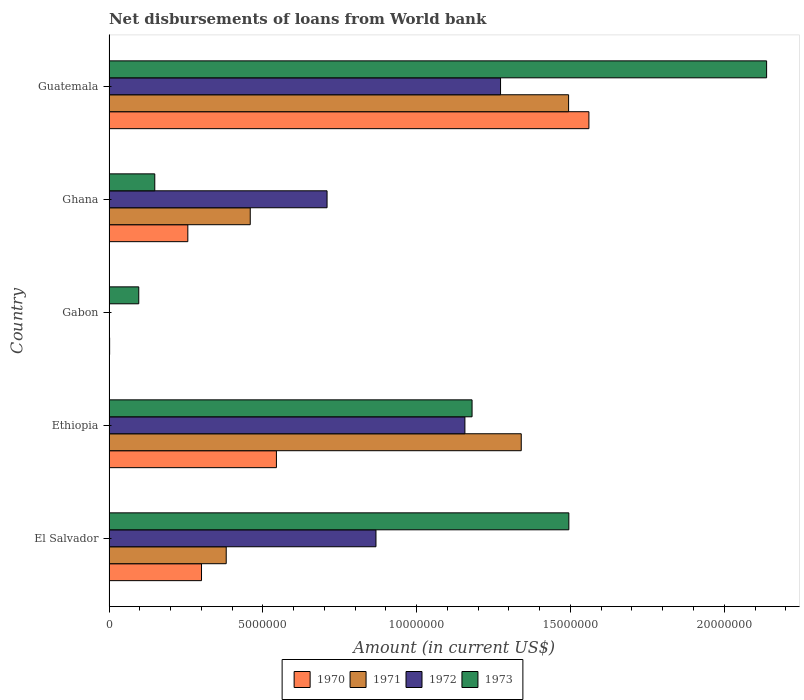How many different coloured bars are there?
Ensure brevity in your answer.  4. Are the number of bars per tick equal to the number of legend labels?
Provide a short and direct response. No. How many bars are there on the 2nd tick from the bottom?
Your response must be concise. 4. What is the label of the 5th group of bars from the top?
Your response must be concise. El Salvador. In how many cases, is the number of bars for a given country not equal to the number of legend labels?
Make the answer very short. 1. What is the amount of loan disbursed from World Bank in 1972 in Gabon?
Offer a very short reply. 0. Across all countries, what is the maximum amount of loan disbursed from World Bank in 1973?
Give a very brief answer. 2.14e+07. In which country was the amount of loan disbursed from World Bank in 1972 maximum?
Give a very brief answer. Guatemala. What is the total amount of loan disbursed from World Bank in 1973 in the graph?
Your response must be concise. 5.06e+07. What is the difference between the amount of loan disbursed from World Bank in 1972 in Ethiopia and that in Guatemala?
Your answer should be very brief. -1.16e+06. What is the difference between the amount of loan disbursed from World Bank in 1970 in El Salvador and the amount of loan disbursed from World Bank in 1972 in Ethiopia?
Ensure brevity in your answer.  -8.56e+06. What is the average amount of loan disbursed from World Bank in 1973 per country?
Your answer should be very brief. 1.01e+07. What is the difference between the amount of loan disbursed from World Bank in 1973 and amount of loan disbursed from World Bank in 1970 in Guatemala?
Your answer should be very brief. 5.78e+06. In how many countries, is the amount of loan disbursed from World Bank in 1972 greater than 19000000 US$?
Provide a short and direct response. 0. What is the ratio of the amount of loan disbursed from World Bank in 1973 in Ghana to that in Guatemala?
Give a very brief answer. 0.07. Is the difference between the amount of loan disbursed from World Bank in 1973 in Ethiopia and Guatemala greater than the difference between the amount of loan disbursed from World Bank in 1970 in Ethiopia and Guatemala?
Provide a succinct answer. Yes. What is the difference between the highest and the second highest amount of loan disbursed from World Bank in 1972?
Offer a very short reply. 1.16e+06. What is the difference between the highest and the lowest amount of loan disbursed from World Bank in 1973?
Give a very brief answer. 2.04e+07. In how many countries, is the amount of loan disbursed from World Bank in 1971 greater than the average amount of loan disbursed from World Bank in 1971 taken over all countries?
Keep it short and to the point. 2. Is it the case that in every country, the sum of the amount of loan disbursed from World Bank in 1971 and amount of loan disbursed from World Bank in 1973 is greater than the sum of amount of loan disbursed from World Bank in 1970 and amount of loan disbursed from World Bank in 1972?
Give a very brief answer. No. Is it the case that in every country, the sum of the amount of loan disbursed from World Bank in 1972 and amount of loan disbursed from World Bank in 1973 is greater than the amount of loan disbursed from World Bank in 1970?
Ensure brevity in your answer.  Yes. How many bars are there?
Keep it short and to the point. 18. Are all the bars in the graph horizontal?
Make the answer very short. Yes. How many countries are there in the graph?
Ensure brevity in your answer.  5. What is the difference between two consecutive major ticks on the X-axis?
Make the answer very short. 5.00e+06. Are the values on the major ticks of X-axis written in scientific E-notation?
Keep it short and to the point. No. Does the graph contain any zero values?
Keep it short and to the point. Yes. Where does the legend appear in the graph?
Keep it short and to the point. Bottom center. What is the title of the graph?
Provide a short and direct response. Net disbursements of loans from World bank. Does "1995" appear as one of the legend labels in the graph?
Make the answer very short. No. What is the label or title of the X-axis?
Provide a short and direct response. Amount (in current US$). What is the Amount (in current US$) in 1970 in El Salvador?
Keep it short and to the point. 3.01e+06. What is the Amount (in current US$) in 1971 in El Salvador?
Provide a succinct answer. 3.81e+06. What is the Amount (in current US$) in 1972 in El Salvador?
Your answer should be very brief. 8.68e+06. What is the Amount (in current US$) in 1973 in El Salvador?
Give a very brief answer. 1.49e+07. What is the Amount (in current US$) of 1970 in Ethiopia?
Give a very brief answer. 5.44e+06. What is the Amount (in current US$) in 1971 in Ethiopia?
Your response must be concise. 1.34e+07. What is the Amount (in current US$) in 1972 in Ethiopia?
Give a very brief answer. 1.16e+07. What is the Amount (in current US$) of 1973 in Ethiopia?
Give a very brief answer. 1.18e+07. What is the Amount (in current US$) in 1970 in Gabon?
Your answer should be compact. 2.00e+04. What is the Amount (in current US$) in 1973 in Gabon?
Your response must be concise. 9.67e+05. What is the Amount (in current US$) in 1970 in Ghana?
Provide a short and direct response. 2.56e+06. What is the Amount (in current US$) in 1971 in Ghana?
Offer a very short reply. 4.59e+06. What is the Amount (in current US$) in 1972 in Ghana?
Your answer should be compact. 7.09e+06. What is the Amount (in current US$) of 1973 in Ghana?
Ensure brevity in your answer.  1.49e+06. What is the Amount (in current US$) in 1970 in Guatemala?
Offer a terse response. 1.56e+07. What is the Amount (in current US$) in 1971 in Guatemala?
Provide a succinct answer. 1.49e+07. What is the Amount (in current US$) in 1972 in Guatemala?
Provide a succinct answer. 1.27e+07. What is the Amount (in current US$) in 1973 in Guatemala?
Offer a terse response. 2.14e+07. Across all countries, what is the maximum Amount (in current US$) of 1970?
Your response must be concise. 1.56e+07. Across all countries, what is the maximum Amount (in current US$) in 1971?
Your answer should be very brief. 1.49e+07. Across all countries, what is the maximum Amount (in current US$) of 1972?
Make the answer very short. 1.27e+07. Across all countries, what is the maximum Amount (in current US$) of 1973?
Offer a very short reply. 2.14e+07. Across all countries, what is the minimum Amount (in current US$) in 1973?
Offer a terse response. 9.67e+05. What is the total Amount (in current US$) in 1970 in the graph?
Offer a terse response. 2.66e+07. What is the total Amount (in current US$) in 1971 in the graph?
Offer a very short reply. 3.67e+07. What is the total Amount (in current US$) in 1972 in the graph?
Make the answer very short. 4.01e+07. What is the total Amount (in current US$) of 1973 in the graph?
Offer a very short reply. 5.06e+07. What is the difference between the Amount (in current US$) in 1970 in El Salvador and that in Ethiopia?
Offer a very short reply. -2.44e+06. What is the difference between the Amount (in current US$) in 1971 in El Salvador and that in Ethiopia?
Keep it short and to the point. -9.59e+06. What is the difference between the Amount (in current US$) in 1972 in El Salvador and that in Ethiopia?
Your answer should be compact. -2.89e+06. What is the difference between the Amount (in current US$) of 1973 in El Salvador and that in Ethiopia?
Offer a very short reply. 3.15e+06. What is the difference between the Amount (in current US$) of 1970 in El Salvador and that in Gabon?
Make the answer very short. 2.99e+06. What is the difference between the Amount (in current US$) in 1973 in El Salvador and that in Gabon?
Your response must be concise. 1.40e+07. What is the difference between the Amount (in current US$) of 1970 in El Salvador and that in Ghana?
Ensure brevity in your answer.  4.45e+05. What is the difference between the Amount (in current US$) in 1971 in El Salvador and that in Ghana?
Make the answer very short. -7.81e+05. What is the difference between the Amount (in current US$) of 1972 in El Salvador and that in Ghana?
Keep it short and to the point. 1.59e+06. What is the difference between the Amount (in current US$) of 1973 in El Salvador and that in Ghana?
Provide a succinct answer. 1.35e+07. What is the difference between the Amount (in current US$) of 1970 in El Salvador and that in Guatemala?
Keep it short and to the point. -1.26e+07. What is the difference between the Amount (in current US$) in 1971 in El Salvador and that in Guatemala?
Your response must be concise. -1.11e+07. What is the difference between the Amount (in current US$) of 1972 in El Salvador and that in Guatemala?
Your response must be concise. -4.05e+06. What is the difference between the Amount (in current US$) in 1973 in El Salvador and that in Guatemala?
Your response must be concise. -6.43e+06. What is the difference between the Amount (in current US$) in 1970 in Ethiopia and that in Gabon?
Your response must be concise. 5.42e+06. What is the difference between the Amount (in current US$) in 1973 in Ethiopia and that in Gabon?
Make the answer very short. 1.08e+07. What is the difference between the Amount (in current US$) of 1970 in Ethiopia and that in Ghana?
Ensure brevity in your answer.  2.88e+06. What is the difference between the Amount (in current US$) of 1971 in Ethiopia and that in Ghana?
Your answer should be very brief. 8.81e+06. What is the difference between the Amount (in current US$) in 1972 in Ethiopia and that in Ghana?
Offer a terse response. 4.48e+06. What is the difference between the Amount (in current US$) of 1973 in Ethiopia and that in Ghana?
Ensure brevity in your answer.  1.03e+07. What is the difference between the Amount (in current US$) in 1970 in Ethiopia and that in Guatemala?
Your answer should be compact. -1.02e+07. What is the difference between the Amount (in current US$) of 1971 in Ethiopia and that in Guatemala?
Your answer should be very brief. -1.54e+06. What is the difference between the Amount (in current US$) of 1972 in Ethiopia and that in Guatemala?
Your answer should be very brief. -1.16e+06. What is the difference between the Amount (in current US$) in 1973 in Ethiopia and that in Guatemala?
Your response must be concise. -9.58e+06. What is the difference between the Amount (in current US$) in 1970 in Gabon and that in Ghana?
Offer a terse response. -2.54e+06. What is the difference between the Amount (in current US$) in 1973 in Gabon and that in Ghana?
Provide a short and direct response. -5.21e+05. What is the difference between the Amount (in current US$) of 1970 in Gabon and that in Guatemala?
Your answer should be compact. -1.56e+07. What is the difference between the Amount (in current US$) of 1973 in Gabon and that in Guatemala?
Give a very brief answer. -2.04e+07. What is the difference between the Amount (in current US$) of 1970 in Ghana and that in Guatemala?
Ensure brevity in your answer.  -1.30e+07. What is the difference between the Amount (in current US$) in 1971 in Ghana and that in Guatemala?
Offer a terse response. -1.03e+07. What is the difference between the Amount (in current US$) in 1972 in Ghana and that in Guatemala?
Give a very brief answer. -5.64e+06. What is the difference between the Amount (in current US$) in 1973 in Ghana and that in Guatemala?
Keep it short and to the point. -1.99e+07. What is the difference between the Amount (in current US$) of 1970 in El Salvador and the Amount (in current US$) of 1971 in Ethiopia?
Provide a succinct answer. -1.04e+07. What is the difference between the Amount (in current US$) of 1970 in El Salvador and the Amount (in current US$) of 1972 in Ethiopia?
Ensure brevity in your answer.  -8.56e+06. What is the difference between the Amount (in current US$) in 1970 in El Salvador and the Amount (in current US$) in 1973 in Ethiopia?
Provide a succinct answer. -8.80e+06. What is the difference between the Amount (in current US$) of 1971 in El Salvador and the Amount (in current US$) of 1972 in Ethiopia?
Offer a very short reply. -7.76e+06. What is the difference between the Amount (in current US$) of 1971 in El Salvador and the Amount (in current US$) of 1973 in Ethiopia?
Offer a very short reply. -7.99e+06. What is the difference between the Amount (in current US$) of 1972 in El Salvador and the Amount (in current US$) of 1973 in Ethiopia?
Your response must be concise. -3.12e+06. What is the difference between the Amount (in current US$) in 1970 in El Salvador and the Amount (in current US$) in 1973 in Gabon?
Give a very brief answer. 2.04e+06. What is the difference between the Amount (in current US$) in 1971 in El Salvador and the Amount (in current US$) in 1973 in Gabon?
Your answer should be compact. 2.84e+06. What is the difference between the Amount (in current US$) in 1972 in El Salvador and the Amount (in current US$) in 1973 in Gabon?
Give a very brief answer. 7.71e+06. What is the difference between the Amount (in current US$) of 1970 in El Salvador and the Amount (in current US$) of 1971 in Ghana?
Ensure brevity in your answer.  -1.58e+06. What is the difference between the Amount (in current US$) of 1970 in El Salvador and the Amount (in current US$) of 1972 in Ghana?
Ensure brevity in your answer.  -4.08e+06. What is the difference between the Amount (in current US$) of 1970 in El Salvador and the Amount (in current US$) of 1973 in Ghana?
Provide a short and direct response. 1.52e+06. What is the difference between the Amount (in current US$) in 1971 in El Salvador and the Amount (in current US$) in 1972 in Ghana?
Provide a succinct answer. -3.28e+06. What is the difference between the Amount (in current US$) of 1971 in El Salvador and the Amount (in current US$) of 1973 in Ghana?
Make the answer very short. 2.32e+06. What is the difference between the Amount (in current US$) of 1972 in El Salvador and the Amount (in current US$) of 1973 in Ghana?
Give a very brief answer. 7.19e+06. What is the difference between the Amount (in current US$) in 1970 in El Salvador and the Amount (in current US$) in 1971 in Guatemala?
Provide a succinct answer. -1.19e+07. What is the difference between the Amount (in current US$) in 1970 in El Salvador and the Amount (in current US$) in 1972 in Guatemala?
Ensure brevity in your answer.  -9.72e+06. What is the difference between the Amount (in current US$) of 1970 in El Salvador and the Amount (in current US$) of 1973 in Guatemala?
Your response must be concise. -1.84e+07. What is the difference between the Amount (in current US$) of 1971 in El Salvador and the Amount (in current US$) of 1972 in Guatemala?
Give a very brief answer. -8.92e+06. What is the difference between the Amount (in current US$) of 1971 in El Salvador and the Amount (in current US$) of 1973 in Guatemala?
Offer a terse response. -1.76e+07. What is the difference between the Amount (in current US$) in 1972 in El Salvador and the Amount (in current US$) in 1973 in Guatemala?
Keep it short and to the point. -1.27e+07. What is the difference between the Amount (in current US$) in 1970 in Ethiopia and the Amount (in current US$) in 1973 in Gabon?
Ensure brevity in your answer.  4.48e+06. What is the difference between the Amount (in current US$) in 1971 in Ethiopia and the Amount (in current US$) in 1973 in Gabon?
Give a very brief answer. 1.24e+07. What is the difference between the Amount (in current US$) of 1972 in Ethiopia and the Amount (in current US$) of 1973 in Gabon?
Make the answer very short. 1.06e+07. What is the difference between the Amount (in current US$) in 1970 in Ethiopia and the Amount (in current US$) in 1971 in Ghana?
Provide a short and direct response. 8.51e+05. What is the difference between the Amount (in current US$) in 1970 in Ethiopia and the Amount (in current US$) in 1972 in Ghana?
Give a very brief answer. -1.65e+06. What is the difference between the Amount (in current US$) in 1970 in Ethiopia and the Amount (in current US$) in 1973 in Ghana?
Provide a short and direct response. 3.95e+06. What is the difference between the Amount (in current US$) in 1971 in Ethiopia and the Amount (in current US$) in 1972 in Ghana?
Your response must be concise. 6.31e+06. What is the difference between the Amount (in current US$) in 1971 in Ethiopia and the Amount (in current US$) in 1973 in Ghana?
Provide a succinct answer. 1.19e+07. What is the difference between the Amount (in current US$) in 1972 in Ethiopia and the Amount (in current US$) in 1973 in Ghana?
Offer a terse response. 1.01e+07. What is the difference between the Amount (in current US$) of 1970 in Ethiopia and the Amount (in current US$) of 1971 in Guatemala?
Your answer should be compact. -9.50e+06. What is the difference between the Amount (in current US$) of 1970 in Ethiopia and the Amount (in current US$) of 1972 in Guatemala?
Give a very brief answer. -7.29e+06. What is the difference between the Amount (in current US$) in 1970 in Ethiopia and the Amount (in current US$) in 1973 in Guatemala?
Keep it short and to the point. -1.59e+07. What is the difference between the Amount (in current US$) of 1971 in Ethiopia and the Amount (in current US$) of 1972 in Guatemala?
Your response must be concise. 6.73e+05. What is the difference between the Amount (in current US$) in 1971 in Ethiopia and the Amount (in current US$) in 1973 in Guatemala?
Keep it short and to the point. -7.98e+06. What is the difference between the Amount (in current US$) in 1972 in Ethiopia and the Amount (in current US$) in 1973 in Guatemala?
Your response must be concise. -9.81e+06. What is the difference between the Amount (in current US$) in 1970 in Gabon and the Amount (in current US$) in 1971 in Ghana?
Provide a succinct answer. -4.57e+06. What is the difference between the Amount (in current US$) in 1970 in Gabon and the Amount (in current US$) in 1972 in Ghana?
Your answer should be compact. -7.07e+06. What is the difference between the Amount (in current US$) of 1970 in Gabon and the Amount (in current US$) of 1973 in Ghana?
Provide a succinct answer. -1.47e+06. What is the difference between the Amount (in current US$) in 1970 in Gabon and the Amount (in current US$) in 1971 in Guatemala?
Ensure brevity in your answer.  -1.49e+07. What is the difference between the Amount (in current US$) of 1970 in Gabon and the Amount (in current US$) of 1972 in Guatemala?
Make the answer very short. -1.27e+07. What is the difference between the Amount (in current US$) of 1970 in Gabon and the Amount (in current US$) of 1973 in Guatemala?
Keep it short and to the point. -2.14e+07. What is the difference between the Amount (in current US$) in 1970 in Ghana and the Amount (in current US$) in 1971 in Guatemala?
Keep it short and to the point. -1.24e+07. What is the difference between the Amount (in current US$) in 1970 in Ghana and the Amount (in current US$) in 1972 in Guatemala?
Your answer should be very brief. -1.02e+07. What is the difference between the Amount (in current US$) in 1970 in Ghana and the Amount (in current US$) in 1973 in Guatemala?
Offer a terse response. -1.88e+07. What is the difference between the Amount (in current US$) in 1971 in Ghana and the Amount (in current US$) in 1972 in Guatemala?
Offer a very short reply. -8.14e+06. What is the difference between the Amount (in current US$) in 1971 in Ghana and the Amount (in current US$) in 1973 in Guatemala?
Provide a succinct answer. -1.68e+07. What is the difference between the Amount (in current US$) in 1972 in Ghana and the Amount (in current US$) in 1973 in Guatemala?
Offer a very short reply. -1.43e+07. What is the average Amount (in current US$) in 1970 per country?
Provide a short and direct response. 5.33e+06. What is the average Amount (in current US$) in 1971 per country?
Offer a terse response. 7.35e+06. What is the average Amount (in current US$) of 1972 per country?
Your answer should be very brief. 8.01e+06. What is the average Amount (in current US$) in 1973 per country?
Give a very brief answer. 1.01e+07. What is the difference between the Amount (in current US$) of 1970 and Amount (in current US$) of 1971 in El Salvador?
Offer a terse response. -8.03e+05. What is the difference between the Amount (in current US$) of 1970 and Amount (in current US$) of 1972 in El Salvador?
Keep it short and to the point. -5.67e+06. What is the difference between the Amount (in current US$) of 1970 and Amount (in current US$) of 1973 in El Salvador?
Ensure brevity in your answer.  -1.19e+07. What is the difference between the Amount (in current US$) in 1971 and Amount (in current US$) in 1972 in El Salvador?
Make the answer very short. -4.87e+06. What is the difference between the Amount (in current US$) of 1971 and Amount (in current US$) of 1973 in El Salvador?
Provide a succinct answer. -1.11e+07. What is the difference between the Amount (in current US$) in 1972 and Amount (in current US$) in 1973 in El Salvador?
Offer a terse response. -6.27e+06. What is the difference between the Amount (in current US$) in 1970 and Amount (in current US$) in 1971 in Ethiopia?
Make the answer very short. -7.96e+06. What is the difference between the Amount (in current US$) in 1970 and Amount (in current US$) in 1972 in Ethiopia?
Ensure brevity in your answer.  -6.13e+06. What is the difference between the Amount (in current US$) in 1970 and Amount (in current US$) in 1973 in Ethiopia?
Provide a succinct answer. -6.36e+06. What is the difference between the Amount (in current US$) of 1971 and Amount (in current US$) of 1972 in Ethiopia?
Keep it short and to the point. 1.83e+06. What is the difference between the Amount (in current US$) in 1971 and Amount (in current US$) in 1973 in Ethiopia?
Provide a short and direct response. 1.60e+06. What is the difference between the Amount (in current US$) of 1972 and Amount (in current US$) of 1973 in Ethiopia?
Offer a terse response. -2.33e+05. What is the difference between the Amount (in current US$) in 1970 and Amount (in current US$) in 1973 in Gabon?
Provide a succinct answer. -9.47e+05. What is the difference between the Amount (in current US$) of 1970 and Amount (in current US$) of 1971 in Ghana?
Give a very brief answer. -2.03e+06. What is the difference between the Amount (in current US$) in 1970 and Amount (in current US$) in 1972 in Ghana?
Provide a succinct answer. -4.53e+06. What is the difference between the Amount (in current US$) in 1970 and Amount (in current US$) in 1973 in Ghana?
Provide a short and direct response. 1.07e+06. What is the difference between the Amount (in current US$) of 1971 and Amount (in current US$) of 1972 in Ghana?
Provide a short and direct response. -2.50e+06. What is the difference between the Amount (in current US$) of 1971 and Amount (in current US$) of 1973 in Ghana?
Offer a terse response. 3.10e+06. What is the difference between the Amount (in current US$) in 1972 and Amount (in current US$) in 1973 in Ghana?
Make the answer very short. 5.60e+06. What is the difference between the Amount (in current US$) in 1970 and Amount (in current US$) in 1972 in Guatemala?
Provide a short and direct response. 2.87e+06. What is the difference between the Amount (in current US$) in 1970 and Amount (in current US$) in 1973 in Guatemala?
Your answer should be compact. -5.78e+06. What is the difference between the Amount (in current US$) of 1971 and Amount (in current US$) of 1972 in Guatemala?
Your response must be concise. 2.21e+06. What is the difference between the Amount (in current US$) of 1971 and Amount (in current US$) of 1973 in Guatemala?
Provide a short and direct response. -6.44e+06. What is the difference between the Amount (in current US$) in 1972 and Amount (in current US$) in 1973 in Guatemala?
Ensure brevity in your answer.  -8.65e+06. What is the ratio of the Amount (in current US$) of 1970 in El Salvador to that in Ethiopia?
Your answer should be very brief. 0.55. What is the ratio of the Amount (in current US$) in 1971 in El Salvador to that in Ethiopia?
Offer a terse response. 0.28. What is the ratio of the Amount (in current US$) in 1972 in El Salvador to that in Ethiopia?
Make the answer very short. 0.75. What is the ratio of the Amount (in current US$) of 1973 in El Salvador to that in Ethiopia?
Make the answer very short. 1.27. What is the ratio of the Amount (in current US$) of 1970 in El Salvador to that in Gabon?
Your response must be concise. 150.35. What is the ratio of the Amount (in current US$) in 1973 in El Salvador to that in Gabon?
Your response must be concise. 15.46. What is the ratio of the Amount (in current US$) of 1970 in El Salvador to that in Ghana?
Keep it short and to the point. 1.17. What is the ratio of the Amount (in current US$) of 1971 in El Salvador to that in Ghana?
Provide a succinct answer. 0.83. What is the ratio of the Amount (in current US$) in 1972 in El Salvador to that in Ghana?
Give a very brief answer. 1.22. What is the ratio of the Amount (in current US$) of 1973 in El Salvador to that in Ghana?
Your response must be concise. 10.05. What is the ratio of the Amount (in current US$) of 1970 in El Salvador to that in Guatemala?
Offer a terse response. 0.19. What is the ratio of the Amount (in current US$) in 1971 in El Salvador to that in Guatemala?
Provide a succinct answer. 0.26. What is the ratio of the Amount (in current US$) of 1972 in El Salvador to that in Guatemala?
Offer a very short reply. 0.68. What is the ratio of the Amount (in current US$) of 1973 in El Salvador to that in Guatemala?
Offer a terse response. 0.7. What is the ratio of the Amount (in current US$) of 1970 in Ethiopia to that in Gabon?
Keep it short and to the point. 272.1. What is the ratio of the Amount (in current US$) in 1973 in Ethiopia to that in Gabon?
Offer a terse response. 12.2. What is the ratio of the Amount (in current US$) of 1970 in Ethiopia to that in Ghana?
Give a very brief answer. 2.12. What is the ratio of the Amount (in current US$) in 1971 in Ethiopia to that in Ghana?
Your answer should be compact. 2.92. What is the ratio of the Amount (in current US$) of 1972 in Ethiopia to that in Ghana?
Your answer should be very brief. 1.63. What is the ratio of the Amount (in current US$) in 1973 in Ethiopia to that in Ghana?
Your answer should be very brief. 7.93. What is the ratio of the Amount (in current US$) of 1970 in Ethiopia to that in Guatemala?
Offer a very short reply. 0.35. What is the ratio of the Amount (in current US$) of 1971 in Ethiopia to that in Guatemala?
Offer a terse response. 0.9. What is the ratio of the Amount (in current US$) of 1972 in Ethiopia to that in Guatemala?
Your answer should be compact. 0.91. What is the ratio of the Amount (in current US$) of 1973 in Ethiopia to that in Guatemala?
Keep it short and to the point. 0.55. What is the ratio of the Amount (in current US$) in 1970 in Gabon to that in Ghana?
Ensure brevity in your answer.  0.01. What is the ratio of the Amount (in current US$) of 1973 in Gabon to that in Ghana?
Your answer should be very brief. 0.65. What is the ratio of the Amount (in current US$) in 1970 in Gabon to that in Guatemala?
Provide a short and direct response. 0. What is the ratio of the Amount (in current US$) in 1973 in Gabon to that in Guatemala?
Your response must be concise. 0.05. What is the ratio of the Amount (in current US$) in 1970 in Ghana to that in Guatemala?
Your answer should be compact. 0.16. What is the ratio of the Amount (in current US$) of 1971 in Ghana to that in Guatemala?
Ensure brevity in your answer.  0.31. What is the ratio of the Amount (in current US$) of 1972 in Ghana to that in Guatemala?
Your response must be concise. 0.56. What is the ratio of the Amount (in current US$) in 1973 in Ghana to that in Guatemala?
Make the answer very short. 0.07. What is the difference between the highest and the second highest Amount (in current US$) in 1970?
Keep it short and to the point. 1.02e+07. What is the difference between the highest and the second highest Amount (in current US$) in 1971?
Offer a terse response. 1.54e+06. What is the difference between the highest and the second highest Amount (in current US$) in 1972?
Offer a very short reply. 1.16e+06. What is the difference between the highest and the second highest Amount (in current US$) of 1973?
Your answer should be very brief. 6.43e+06. What is the difference between the highest and the lowest Amount (in current US$) in 1970?
Your response must be concise. 1.56e+07. What is the difference between the highest and the lowest Amount (in current US$) of 1971?
Ensure brevity in your answer.  1.49e+07. What is the difference between the highest and the lowest Amount (in current US$) in 1972?
Provide a short and direct response. 1.27e+07. What is the difference between the highest and the lowest Amount (in current US$) of 1973?
Make the answer very short. 2.04e+07. 